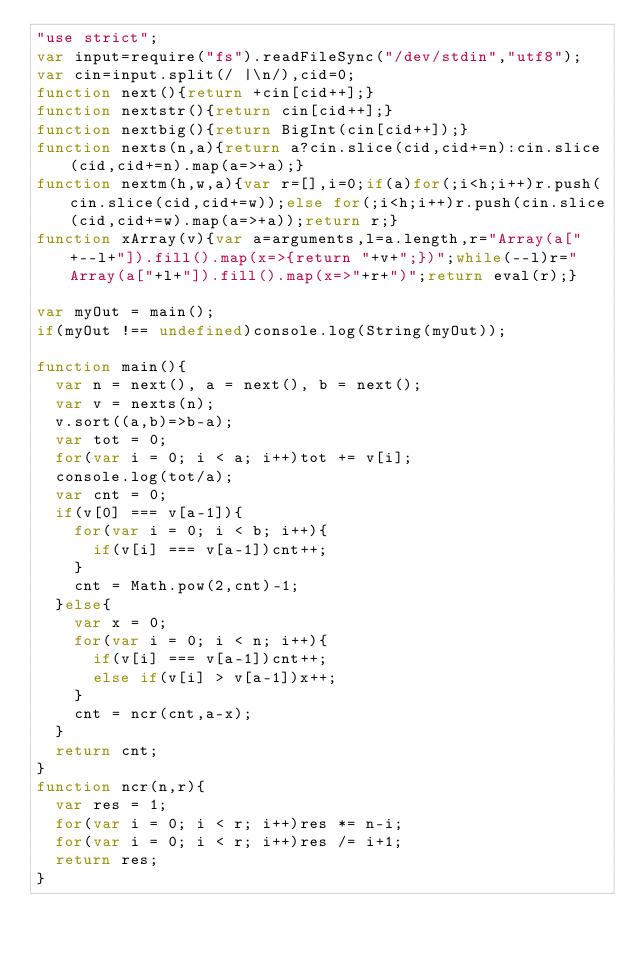Convert code to text. <code><loc_0><loc_0><loc_500><loc_500><_JavaScript_>"use strict";
var input=require("fs").readFileSync("/dev/stdin","utf8");
var cin=input.split(/ |\n/),cid=0;
function next(){return +cin[cid++];}
function nextstr(){return cin[cid++];}
function nextbig(){return BigInt(cin[cid++]);}
function nexts(n,a){return a?cin.slice(cid,cid+=n):cin.slice(cid,cid+=n).map(a=>+a);}
function nextm(h,w,a){var r=[],i=0;if(a)for(;i<h;i++)r.push(cin.slice(cid,cid+=w));else for(;i<h;i++)r.push(cin.slice(cid,cid+=w).map(a=>+a));return r;}
function xArray(v){var a=arguments,l=a.length,r="Array(a["+--l+"]).fill().map(x=>{return "+v+";})";while(--l)r="Array(a["+l+"]).fill().map(x=>"+r+")";return eval(r);}

var myOut = main();
if(myOut !== undefined)console.log(String(myOut));

function main(){
  var n = next(), a = next(), b = next();
  var v = nexts(n);
  v.sort((a,b)=>b-a);
  var tot = 0;
  for(var i = 0; i < a; i++)tot += v[i];
  console.log(tot/a);
  var cnt = 0;
  if(v[0] === v[a-1]){
    for(var i = 0; i < b; i++){
      if(v[i] === v[a-1])cnt++;
    }
    cnt = Math.pow(2,cnt)-1;
  }else{
    var x = 0;
    for(var i = 0; i < n; i++){
      if(v[i] === v[a-1])cnt++;
      else if(v[i] > v[a-1])x++;
    }
    cnt = ncr(cnt,a-x);
  }
  return cnt;
}
function ncr(n,r){
  var res = 1;
  for(var i = 0; i < r; i++)res *= n-i;
  for(var i = 0; i < r; i++)res /= i+1;
  return res;
}</code> 